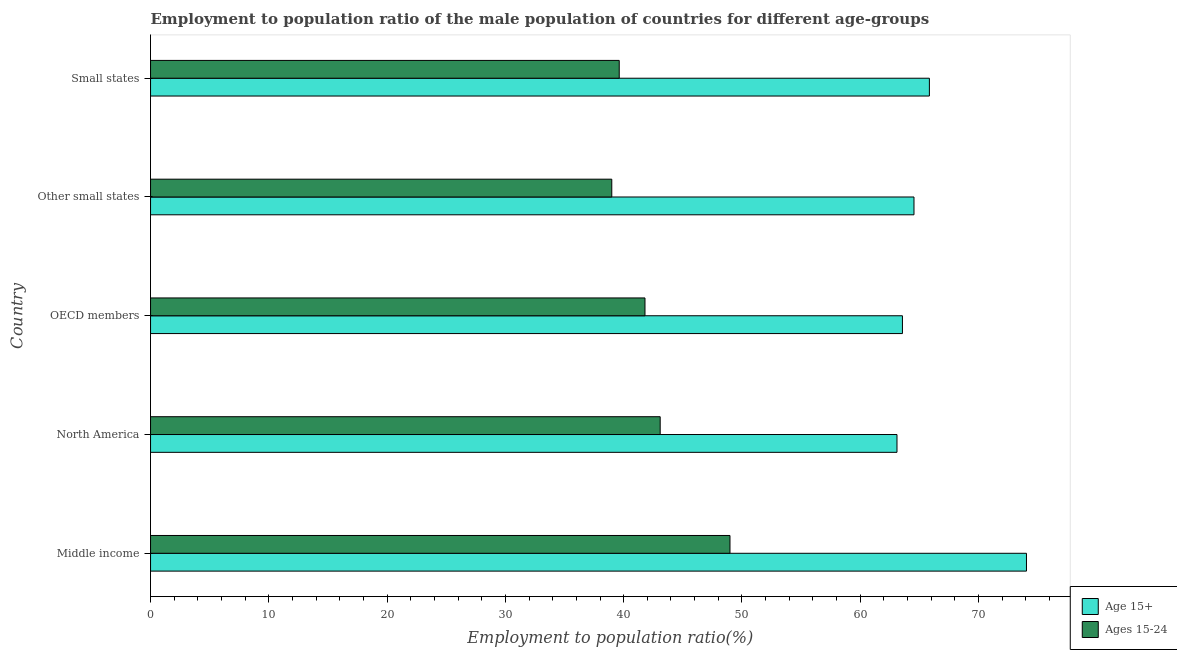How many different coloured bars are there?
Make the answer very short. 2. Are the number of bars per tick equal to the number of legend labels?
Your response must be concise. Yes. Are the number of bars on each tick of the Y-axis equal?
Your answer should be very brief. Yes. How many bars are there on the 3rd tick from the top?
Keep it short and to the point. 2. How many bars are there on the 3rd tick from the bottom?
Make the answer very short. 2. What is the label of the 2nd group of bars from the top?
Offer a terse response. Other small states. In how many cases, is the number of bars for a given country not equal to the number of legend labels?
Your answer should be very brief. 0. What is the employment to population ratio(age 15-24) in North America?
Your answer should be very brief. 43.09. Across all countries, what is the maximum employment to population ratio(age 15-24)?
Your answer should be compact. 48.99. Across all countries, what is the minimum employment to population ratio(age 15+)?
Your answer should be compact. 63.11. In which country was the employment to population ratio(age 15-24) maximum?
Provide a short and direct response. Middle income. In which country was the employment to population ratio(age 15-24) minimum?
Offer a very short reply. Other small states. What is the total employment to population ratio(age 15-24) in the graph?
Your answer should be very brief. 212.51. What is the difference between the employment to population ratio(age 15-24) in North America and that in Other small states?
Keep it short and to the point. 4.09. What is the difference between the employment to population ratio(age 15-24) in Small states and the employment to population ratio(age 15+) in OECD members?
Offer a very short reply. -23.94. What is the average employment to population ratio(age 15-24) per country?
Your answer should be very brief. 42.5. What is the difference between the employment to population ratio(age 15-24) and employment to population ratio(age 15+) in North America?
Offer a terse response. -20.02. What is the ratio of the employment to population ratio(age 15-24) in OECD members to that in Small states?
Provide a short and direct response. 1.05. What is the difference between the highest and the second highest employment to population ratio(age 15-24)?
Give a very brief answer. 5.9. What is the difference between the highest and the lowest employment to population ratio(age 15-24)?
Keep it short and to the point. 9.99. In how many countries, is the employment to population ratio(age 15-24) greater than the average employment to population ratio(age 15-24) taken over all countries?
Your response must be concise. 2. Is the sum of the employment to population ratio(age 15+) in Middle income and Small states greater than the maximum employment to population ratio(age 15-24) across all countries?
Give a very brief answer. Yes. What does the 1st bar from the top in Small states represents?
Provide a succinct answer. Ages 15-24. What does the 2nd bar from the bottom in Middle income represents?
Keep it short and to the point. Ages 15-24. How many bars are there?
Keep it short and to the point. 10. Are all the bars in the graph horizontal?
Ensure brevity in your answer.  Yes. What is the difference between two consecutive major ticks on the X-axis?
Give a very brief answer. 10. Does the graph contain any zero values?
Your response must be concise. No. Does the graph contain grids?
Offer a terse response. No. What is the title of the graph?
Offer a terse response. Employment to population ratio of the male population of countries for different age-groups. Does "Goods" appear as one of the legend labels in the graph?
Offer a very short reply. No. What is the label or title of the Y-axis?
Keep it short and to the point. Country. What is the Employment to population ratio(%) of Age 15+ in Middle income?
Keep it short and to the point. 74.06. What is the Employment to population ratio(%) of Ages 15-24 in Middle income?
Your response must be concise. 48.99. What is the Employment to population ratio(%) of Age 15+ in North America?
Your answer should be very brief. 63.11. What is the Employment to population ratio(%) of Ages 15-24 in North America?
Your answer should be compact. 43.09. What is the Employment to population ratio(%) of Age 15+ in OECD members?
Your answer should be compact. 63.57. What is the Employment to population ratio(%) in Ages 15-24 in OECD members?
Your response must be concise. 41.8. What is the Employment to population ratio(%) of Age 15+ in Other small states?
Offer a terse response. 64.55. What is the Employment to population ratio(%) of Ages 15-24 in Other small states?
Keep it short and to the point. 39. What is the Employment to population ratio(%) in Age 15+ in Small states?
Your response must be concise. 65.85. What is the Employment to population ratio(%) of Ages 15-24 in Small states?
Your answer should be very brief. 39.63. Across all countries, what is the maximum Employment to population ratio(%) in Age 15+?
Ensure brevity in your answer.  74.06. Across all countries, what is the maximum Employment to population ratio(%) in Ages 15-24?
Offer a terse response. 48.99. Across all countries, what is the minimum Employment to population ratio(%) of Age 15+?
Make the answer very short. 63.11. Across all countries, what is the minimum Employment to population ratio(%) of Ages 15-24?
Your answer should be compact. 39. What is the total Employment to population ratio(%) in Age 15+ in the graph?
Provide a short and direct response. 331.13. What is the total Employment to population ratio(%) in Ages 15-24 in the graph?
Your response must be concise. 212.51. What is the difference between the Employment to population ratio(%) in Age 15+ in Middle income and that in North America?
Provide a succinct answer. 10.95. What is the difference between the Employment to population ratio(%) of Ages 15-24 in Middle income and that in North America?
Offer a very short reply. 5.9. What is the difference between the Employment to population ratio(%) in Age 15+ in Middle income and that in OECD members?
Provide a succinct answer. 10.49. What is the difference between the Employment to population ratio(%) of Ages 15-24 in Middle income and that in OECD members?
Ensure brevity in your answer.  7.19. What is the difference between the Employment to population ratio(%) in Age 15+ in Middle income and that in Other small states?
Your answer should be compact. 9.51. What is the difference between the Employment to population ratio(%) in Ages 15-24 in Middle income and that in Other small states?
Ensure brevity in your answer.  9.99. What is the difference between the Employment to population ratio(%) in Age 15+ in Middle income and that in Small states?
Offer a very short reply. 8.21. What is the difference between the Employment to population ratio(%) in Ages 15-24 in Middle income and that in Small states?
Your response must be concise. 9.36. What is the difference between the Employment to population ratio(%) in Age 15+ in North America and that in OECD members?
Provide a short and direct response. -0.46. What is the difference between the Employment to population ratio(%) of Ages 15-24 in North America and that in OECD members?
Keep it short and to the point. 1.29. What is the difference between the Employment to population ratio(%) in Age 15+ in North America and that in Other small states?
Provide a succinct answer. -1.44. What is the difference between the Employment to population ratio(%) of Ages 15-24 in North America and that in Other small states?
Provide a succinct answer. 4.09. What is the difference between the Employment to population ratio(%) of Age 15+ in North America and that in Small states?
Offer a terse response. -2.74. What is the difference between the Employment to population ratio(%) of Ages 15-24 in North America and that in Small states?
Your answer should be compact. 3.46. What is the difference between the Employment to population ratio(%) in Age 15+ in OECD members and that in Other small states?
Offer a very short reply. -0.98. What is the difference between the Employment to population ratio(%) in Ages 15-24 in OECD members and that in Other small states?
Ensure brevity in your answer.  2.81. What is the difference between the Employment to population ratio(%) of Age 15+ in OECD members and that in Small states?
Your answer should be very brief. -2.28. What is the difference between the Employment to population ratio(%) in Ages 15-24 in OECD members and that in Small states?
Your answer should be very brief. 2.18. What is the difference between the Employment to population ratio(%) in Age 15+ in Other small states and that in Small states?
Your answer should be compact. -1.3. What is the difference between the Employment to population ratio(%) of Ages 15-24 in Other small states and that in Small states?
Your answer should be very brief. -0.63. What is the difference between the Employment to population ratio(%) in Age 15+ in Middle income and the Employment to population ratio(%) in Ages 15-24 in North America?
Provide a succinct answer. 30.97. What is the difference between the Employment to population ratio(%) in Age 15+ in Middle income and the Employment to population ratio(%) in Ages 15-24 in OECD members?
Your answer should be very brief. 32.25. What is the difference between the Employment to population ratio(%) in Age 15+ in Middle income and the Employment to population ratio(%) in Ages 15-24 in Other small states?
Your response must be concise. 35.06. What is the difference between the Employment to population ratio(%) in Age 15+ in Middle income and the Employment to population ratio(%) in Ages 15-24 in Small states?
Keep it short and to the point. 34.43. What is the difference between the Employment to population ratio(%) of Age 15+ in North America and the Employment to population ratio(%) of Ages 15-24 in OECD members?
Provide a succinct answer. 21.31. What is the difference between the Employment to population ratio(%) of Age 15+ in North America and the Employment to population ratio(%) of Ages 15-24 in Other small states?
Your answer should be compact. 24.11. What is the difference between the Employment to population ratio(%) in Age 15+ in North America and the Employment to population ratio(%) in Ages 15-24 in Small states?
Provide a short and direct response. 23.48. What is the difference between the Employment to population ratio(%) in Age 15+ in OECD members and the Employment to population ratio(%) in Ages 15-24 in Other small states?
Make the answer very short. 24.57. What is the difference between the Employment to population ratio(%) in Age 15+ in OECD members and the Employment to population ratio(%) in Ages 15-24 in Small states?
Offer a terse response. 23.94. What is the difference between the Employment to population ratio(%) of Age 15+ in Other small states and the Employment to population ratio(%) of Ages 15-24 in Small states?
Your response must be concise. 24.92. What is the average Employment to population ratio(%) in Age 15+ per country?
Offer a very short reply. 66.23. What is the average Employment to population ratio(%) of Ages 15-24 per country?
Your answer should be compact. 42.5. What is the difference between the Employment to population ratio(%) of Age 15+ and Employment to population ratio(%) of Ages 15-24 in Middle income?
Ensure brevity in your answer.  25.07. What is the difference between the Employment to population ratio(%) of Age 15+ and Employment to population ratio(%) of Ages 15-24 in North America?
Your response must be concise. 20.02. What is the difference between the Employment to population ratio(%) in Age 15+ and Employment to population ratio(%) in Ages 15-24 in OECD members?
Offer a terse response. 21.77. What is the difference between the Employment to population ratio(%) of Age 15+ and Employment to population ratio(%) of Ages 15-24 in Other small states?
Offer a very short reply. 25.55. What is the difference between the Employment to population ratio(%) of Age 15+ and Employment to population ratio(%) of Ages 15-24 in Small states?
Make the answer very short. 26.22. What is the ratio of the Employment to population ratio(%) in Age 15+ in Middle income to that in North America?
Offer a very short reply. 1.17. What is the ratio of the Employment to population ratio(%) of Ages 15-24 in Middle income to that in North America?
Ensure brevity in your answer.  1.14. What is the ratio of the Employment to population ratio(%) in Age 15+ in Middle income to that in OECD members?
Offer a very short reply. 1.17. What is the ratio of the Employment to population ratio(%) in Ages 15-24 in Middle income to that in OECD members?
Offer a very short reply. 1.17. What is the ratio of the Employment to population ratio(%) in Age 15+ in Middle income to that in Other small states?
Your answer should be very brief. 1.15. What is the ratio of the Employment to population ratio(%) in Ages 15-24 in Middle income to that in Other small states?
Provide a short and direct response. 1.26. What is the ratio of the Employment to population ratio(%) of Age 15+ in Middle income to that in Small states?
Your answer should be very brief. 1.12. What is the ratio of the Employment to population ratio(%) in Ages 15-24 in Middle income to that in Small states?
Your answer should be very brief. 1.24. What is the ratio of the Employment to population ratio(%) of Age 15+ in North America to that in OECD members?
Give a very brief answer. 0.99. What is the ratio of the Employment to population ratio(%) of Ages 15-24 in North America to that in OECD members?
Your answer should be compact. 1.03. What is the ratio of the Employment to population ratio(%) of Age 15+ in North America to that in Other small states?
Provide a succinct answer. 0.98. What is the ratio of the Employment to population ratio(%) in Ages 15-24 in North America to that in Other small states?
Give a very brief answer. 1.1. What is the ratio of the Employment to population ratio(%) of Age 15+ in North America to that in Small states?
Ensure brevity in your answer.  0.96. What is the ratio of the Employment to population ratio(%) of Ages 15-24 in North America to that in Small states?
Provide a short and direct response. 1.09. What is the ratio of the Employment to population ratio(%) of Age 15+ in OECD members to that in Other small states?
Your answer should be very brief. 0.98. What is the ratio of the Employment to population ratio(%) of Ages 15-24 in OECD members to that in Other small states?
Ensure brevity in your answer.  1.07. What is the ratio of the Employment to population ratio(%) of Age 15+ in OECD members to that in Small states?
Keep it short and to the point. 0.97. What is the ratio of the Employment to population ratio(%) in Ages 15-24 in OECD members to that in Small states?
Your answer should be compact. 1.05. What is the ratio of the Employment to population ratio(%) in Age 15+ in Other small states to that in Small states?
Offer a terse response. 0.98. What is the ratio of the Employment to population ratio(%) in Ages 15-24 in Other small states to that in Small states?
Offer a very short reply. 0.98. What is the difference between the highest and the second highest Employment to population ratio(%) in Age 15+?
Provide a succinct answer. 8.21. What is the difference between the highest and the second highest Employment to population ratio(%) of Ages 15-24?
Ensure brevity in your answer.  5.9. What is the difference between the highest and the lowest Employment to population ratio(%) in Age 15+?
Provide a succinct answer. 10.95. What is the difference between the highest and the lowest Employment to population ratio(%) of Ages 15-24?
Offer a very short reply. 9.99. 